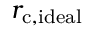<formula> <loc_0><loc_0><loc_500><loc_500>r _ { c , i d e a l }</formula> 